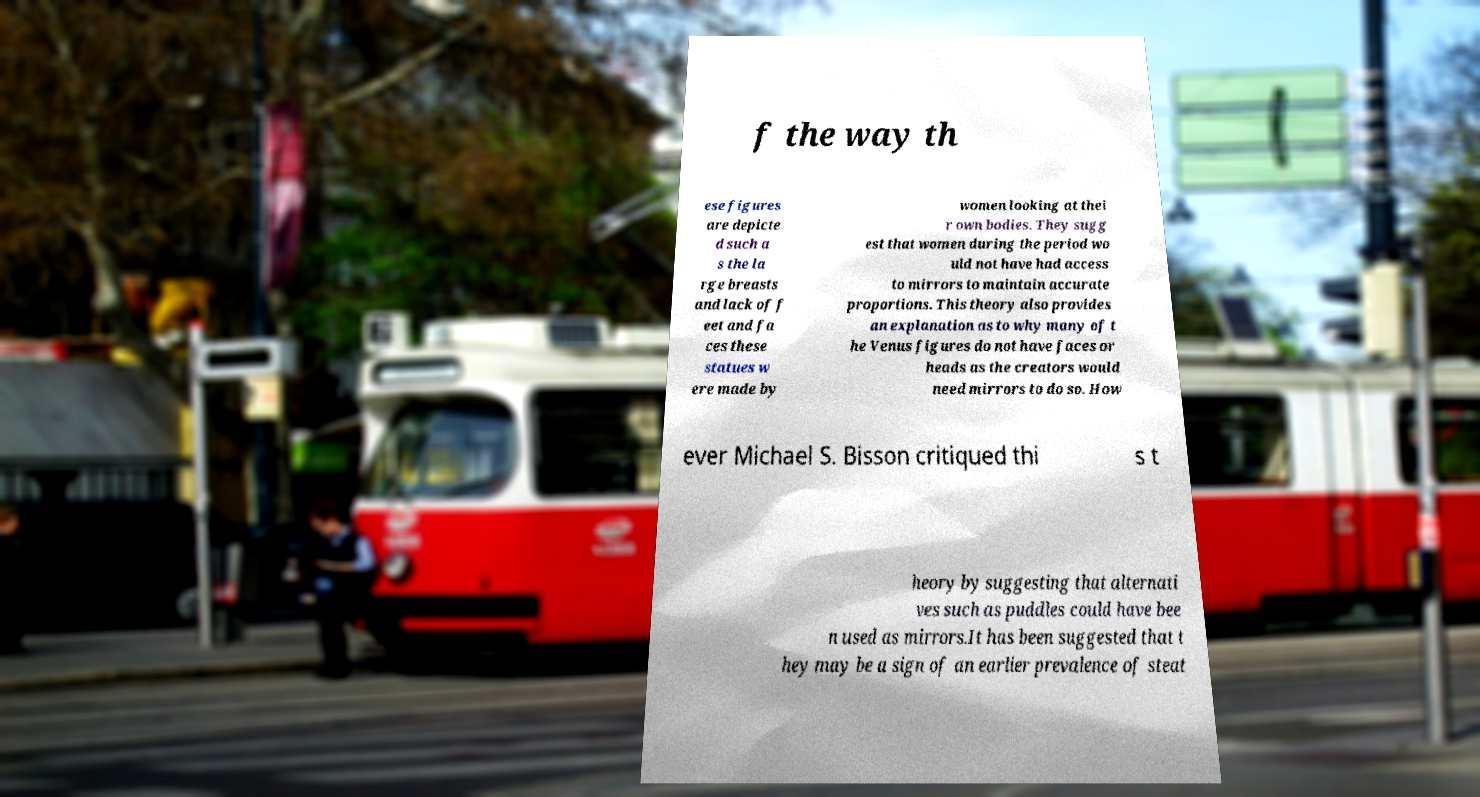What messages or text are displayed in this image? I need them in a readable, typed format. f the way th ese figures are depicte d such a s the la rge breasts and lack of f eet and fa ces these statues w ere made by women looking at thei r own bodies. They sugg est that women during the period wo uld not have had access to mirrors to maintain accurate proportions. This theory also provides an explanation as to why many of t he Venus figures do not have faces or heads as the creators would need mirrors to do so. How ever Michael S. Bisson critiqued thi s t heory by suggesting that alternati ves such as puddles could have bee n used as mirrors.It has been suggested that t hey may be a sign of an earlier prevalence of steat 